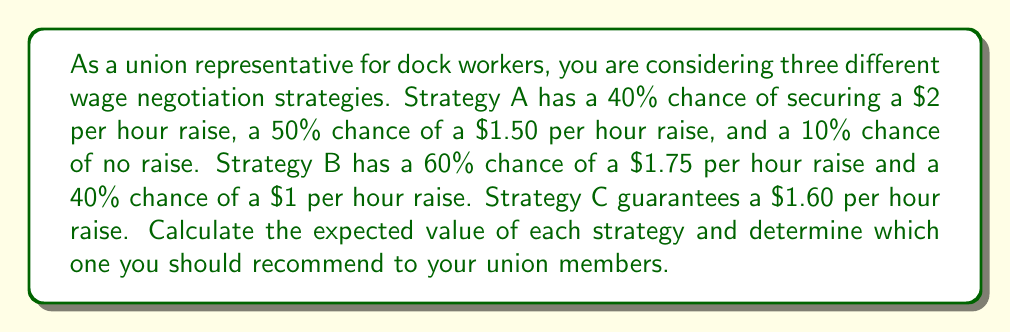Help me with this question. To solve this problem, we need to calculate the expected value of each strategy and compare them. The expected value is the sum of each possible outcome multiplied by its probability.

1. Strategy A:
   Let's calculate the expected value (EV) for Strategy A:
   $$EV_A = (0.40 \times $2) + (0.50 \times $1.50) + (0.10 \times $0)$$
   $$EV_A = $0.80 + $0.75 + $0$$
   $$EV_A = $1.55$$

2. Strategy B:
   Now, let's calculate the expected value for Strategy B:
   $$EV_B = (0.60 \times $1.75) + (0.40 \times $1)$$
   $$EV_B = $1.05 + $0.40$$
   $$EV_B = $1.45$$

3. Strategy C:
   Strategy C guarantees a $1.60 per hour raise, so its expected value is simply:
   $$EV_C = $1.60$$

Comparing the expected values:
$$EV_A = $1.55$$
$$EV_B = $1.45$$
$$EV_C = $1.60$$

Strategy C has the highest expected value, followed by Strategy A, and then Strategy B.
Answer: The expected values for each strategy are:
Strategy A: $1.55 per hour
Strategy B: $1.45 per hour
Strategy C: $1.60 per hour

As a union representative, you should recommend Strategy C to your union members, as it has the highest expected value of $1.60 per hour and guarantees a raise for all workers. 